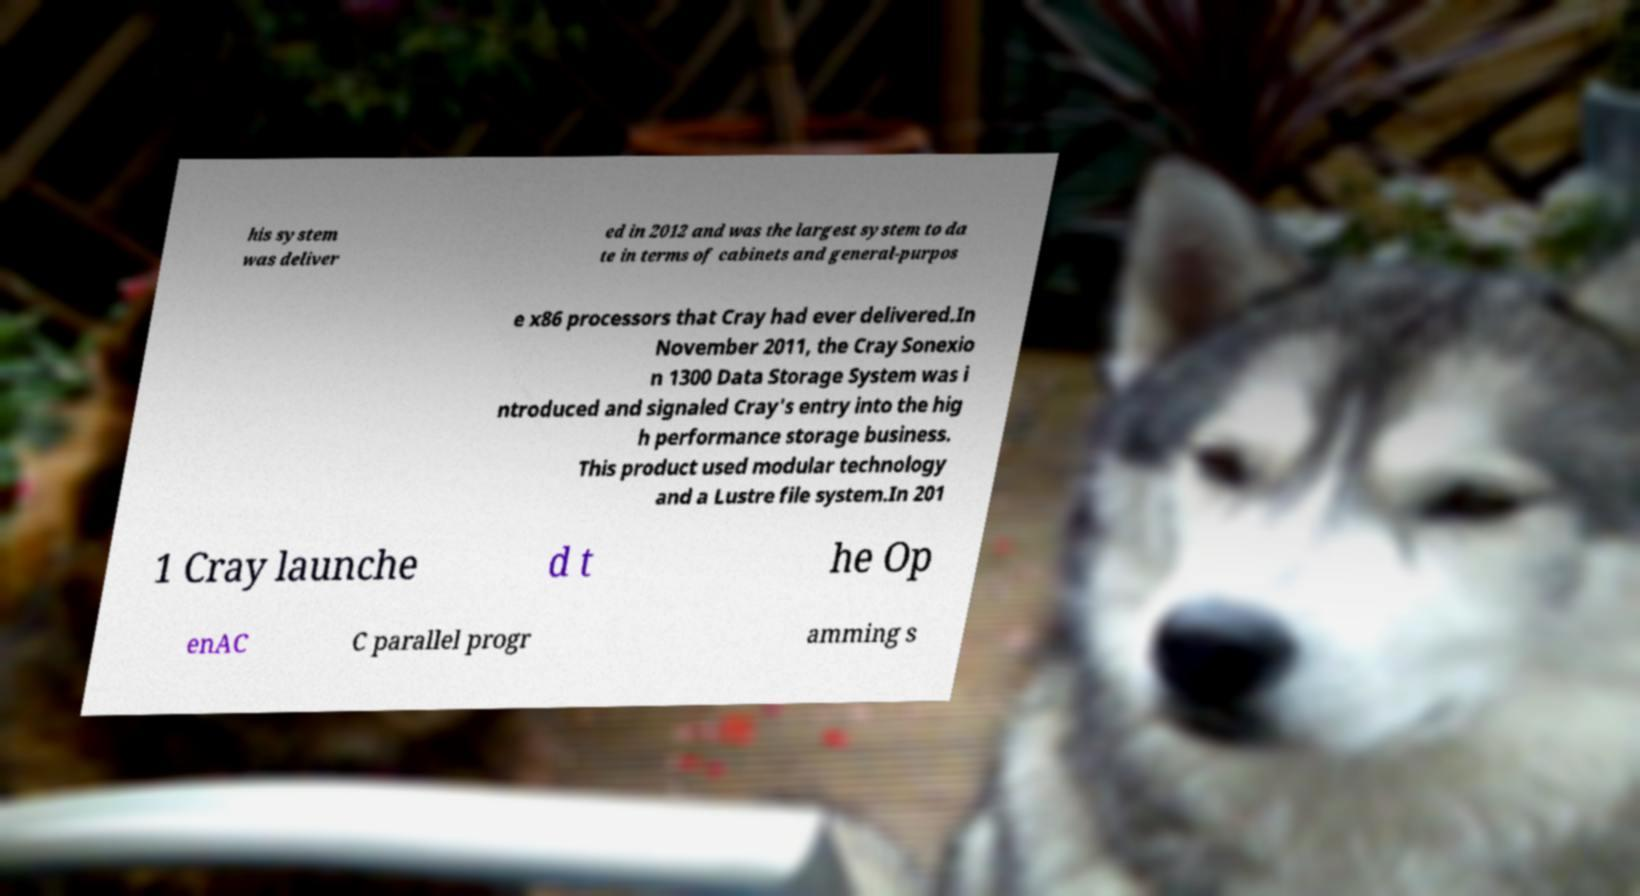For documentation purposes, I need the text within this image transcribed. Could you provide that? his system was deliver ed in 2012 and was the largest system to da te in terms of cabinets and general-purpos e x86 processors that Cray had ever delivered.In November 2011, the Cray Sonexio n 1300 Data Storage System was i ntroduced and signaled Cray's entry into the hig h performance storage business. This product used modular technology and a Lustre file system.In 201 1 Cray launche d t he Op enAC C parallel progr amming s 